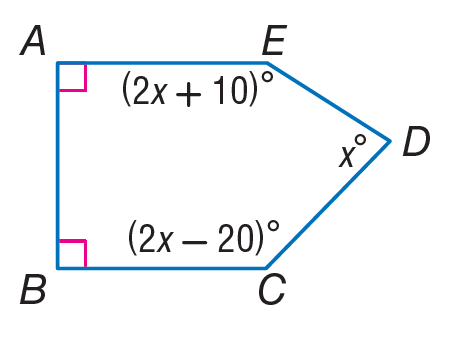Answer the mathemtical geometry problem and directly provide the correct option letter.
Question: Find m \angle B.
Choices: A: 90 B: 180 C: 270 D: 360 A 